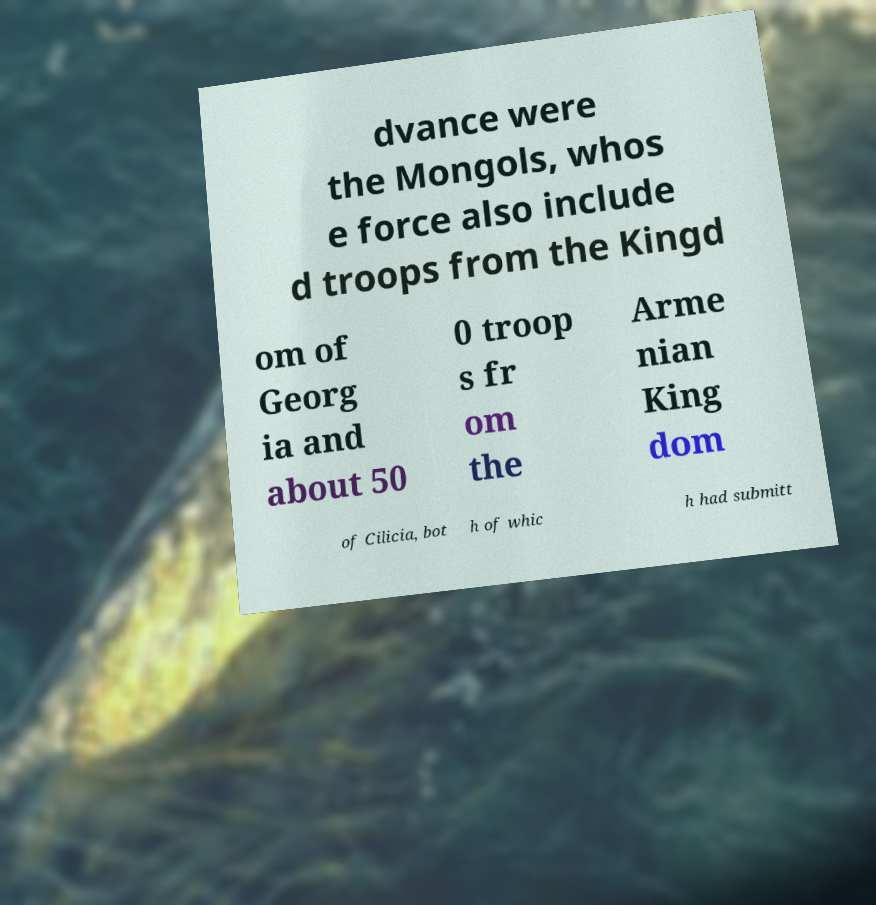For documentation purposes, I need the text within this image transcribed. Could you provide that? dvance were the Mongols, whos e force also include d troops from the Kingd om of Georg ia and about 50 0 troop s fr om the Arme nian King dom of Cilicia, bot h of whic h had submitt 